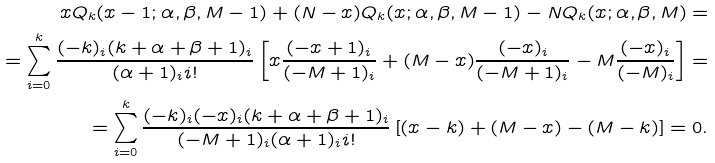<formula> <loc_0><loc_0><loc_500><loc_500>x Q _ { k } ( x - 1 ; \alpha , \beta , M - 1 ) + ( N - x ) Q _ { k } ( x ; \alpha , \beta , M - 1 ) - N Q _ { k } ( x ; \alpha , \beta , M ) = \\ = \sum _ { i = 0 } ^ { k } \frac { ( - k ) _ { i } ( k + \alpha + \beta + 1 ) _ { i } } { ( \alpha + 1 ) _ { i } i ! } \left [ x \frac { ( - x + 1 ) _ { i } } { ( - M + 1 ) _ { i } } + ( M - x ) \frac { ( - x ) _ { i } } { ( - M + 1 ) _ { i } } - M \frac { ( - x ) _ { i } } { ( - M ) _ { i } } \right ] = \\ = \sum _ { i = 0 } ^ { k } \frac { ( - k ) _ { i } ( - x ) _ { i } ( k + \alpha + \beta + 1 ) _ { i } } { ( - M + 1 ) _ { i } ( \alpha + 1 ) _ { i } i ! } \left [ ( x - k ) + ( M - x ) - ( M - k ) \right ] = 0 .</formula> 